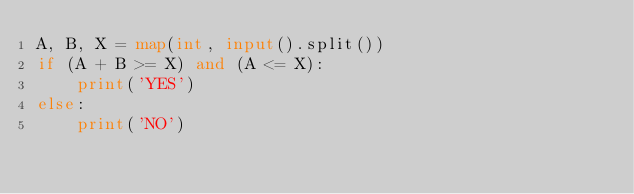<code> <loc_0><loc_0><loc_500><loc_500><_Python_>A, B, X = map(int, input().split())
if (A + B >= X) and (A <= X):
    print('YES')
else:
    print('NO')
</code> 